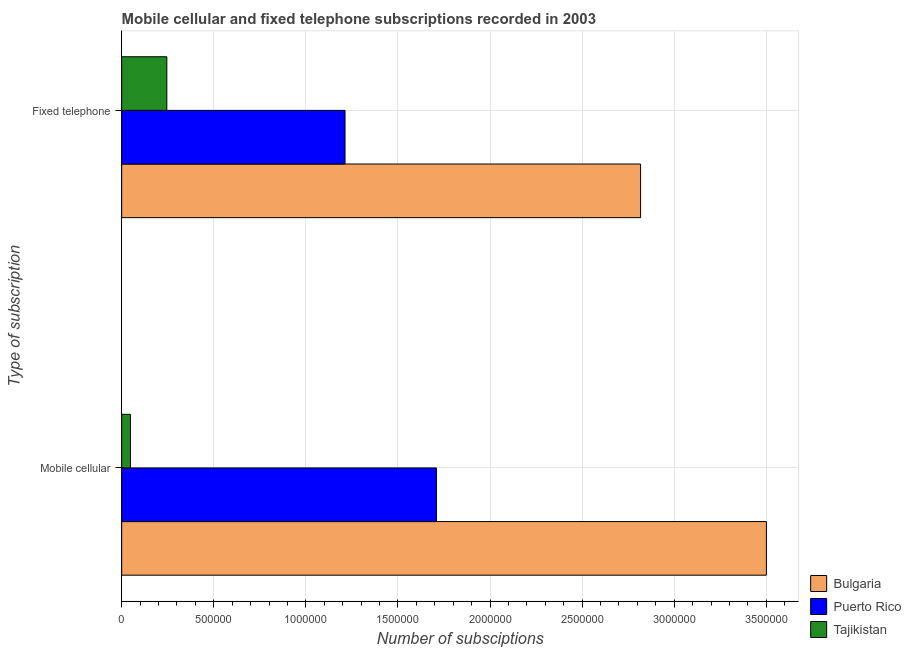How many different coloured bars are there?
Your response must be concise. 3. What is the label of the 2nd group of bars from the top?
Provide a succinct answer. Mobile cellular. What is the number of fixed telephone subscriptions in Bulgaria?
Provide a succinct answer. 2.82e+06. Across all countries, what is the maximum number of mobile cellular subscriptions?
Provide a short and direct response. 3.50e+06. Across all countries, what is the minimum number of fixed telephone subscriptions?
Make the answer very short. 2.45e+05. In which country was the number of fixed telephone subscriptions minimum?
Your answer should be very brief. Tajikistan. What is the total number of fixed telephone subscriptions in the graph?
Offer a terse response. 4.28e+06. What is the difference between the number of fixed telephone subscriptions in Bulgaria and that in Puerto Rico?
Offer a very short reply. 1.60e+06. What is the difference between the number of mobile cellular subscriptions in Bulgaria and the number of fixed telephone subscriptions in Tajikistan?
Ensure brevity in your answer.  3.26e+06. What is the average number of fixed telephone subscriptions per country?
Keep it short and to the point. 1.43e+06. What is the difference between the number of fixed telephone subscriptions and number of mobile cellular subscriptions in Tajikistan?
Provide a succinct answer. 1.98e+05. What is the ratio of the number of fixed telephone subscriptions in Tajikistan to that in Bulgaria?
Make the answer very short. 0.09. Is the number of mobile cellular subscriptions in Puerto Rico less than that in Bulgaria?
Your answer should be compact. Yes. In how many countries, is the number of fixed telephone subscriptions greater than the average number of fixed telephone subscriptions taken over all countries?
Provide a short and direct response. 1. What does the 2nd bar from the top in Fixed telephone represents?
Offer a terse response. Puerto Rico. What is the difference between two consecutive major ticks on the X-axis?
Your answer should be compact. 5.00e+05. Does the graph contain any zero values?
Provide a short and direct response. No. Does the graph contain grids?
Provide a short and direct response. Yes. Where does the legend appear in the graph?
Keep it short and to the point. Bottom right. What is the title of the graph?
Offer a very short reply. Mobile cellular and fixed telephone subscriptions recorded in 2003. What is the label or title of the X-axis?
Offer a very short reply. Number of subsciptions. What is the label or title of the Y-axis?
Offer a very short reply. Type of subscription. What is the Number of subsciptions in Bulgaria in Mobile cellular?
Give a very brief answer. 3.50e+06. What is the Number of subsciptions in Puerto Rico in Mobile cellular?
Give a very brief answer. 1.71e+06. What is the Number of subsciptions in Tajikistan in Mobile cellular?
Offer a very short reply. 4.76e+04. What is the Number of subsciptions in Bulgaria in Fixed telephone?
Provide a succinct answer. 2.82e+06. What is the Number of subsciptions in Puerto Rico in Fixed telephone?
Keep it short and to the point. 1.21e+06. What is the Number of subsciptions of Tajikistan in Fixed telephone?
Offer a very short reply. 2.45e+05. Across all Type of subscription, what is the maximum Number of subsciptions of Bulgaria?
Ensure brevity in your answer.  3.50e+06. Across all Type of subscription, what is the maximum Number of subsciptions of Puerto Rico?
Make the answer very short. 1.71e+06. Across all Type of subscription, what is the maximum Number of subsciptions of Tajikistan?
Provide a succinct answer. 2.45e+05. Across all Type of subscription, what is the minimum Number of subsciptions of Bulgaria?
Offer a very short reply. 2.82e+06. Across all Type of subscription, what is the minimum Number of subsciptions of Puerto Rico?
Provide a short and direct response. 1.21e+06. Across all Type of subscription, what is the minimum Number of subsciptions in Tajikistan?
Provide a short and direct response. 4.76e+04. What is the total Number of subsciptions of Bulgaria in the graph?
Your answer should be compact. 6.32e+06. What is the total Number of subsciptions in Puerto Rico in the graph?
Offer a terse response. 2.92e+06. What is the total Number of subsciptions in Tajikistan in the graph?
Your answer should be very brief. 2.93e+05. What is the difference between the Number of subsciptions in Bulgaria in Mobile cellular and that in Fixed telephone?
Your answer should be very brief. 6.83e+05. What is the difference between the Number of subsciptions in Puerto Rico in Mobile cellular and that in Fixed telephone?
Keep it short and to the point. 4.96e+05. What is the difference between the Number of subsciptions of Tajikistan in Mobile cellular and that in Fixed telephone?
Your answer should be very brief. -1.98e+05. What is the difference between the Number of subsciptions in Bulgaria in Mobile cellular and the Number of subsciptions in Puerto Rico in Fixed telephone?
Make the answer very short. 2.29e+06. What is the difference between the Number of subsciptions of Bulgaria in Mobile cellular and the Number of subsciptions of Tajikistan in Fixed telephone?
Your answer should be very brief. 3.26e+06. What is the difference between the Number of subsciptions in Puerto Rico in Mobile cellular and the Number of subsciptions in Tajikistan in Fixed telephone?
Your response must be concise. 1.46e+06. What is the average Number of subsciptions of Bulgaria per Type of subscription?
Your response must be concise. 3.16e+06. What is the average Number of subsciptions in Puerto Rico per Type of subscription?
Your answer should be compact. 1.46e+06. What is the average Number of subsciptions in Tajikistan per Type of subscription?
Ensure brevity in your answer.  1.46e+05. What is the difference between the Number of subsciptions of Bulgaria and Number of subsciptions of Puerto Rico in Mobile cellular?
Offer a terse response. 1.79e+06. What is the difference between the Number of subsciptions in Bulgaria and Number of subsciptions in Tajikistan in Mobile cellular?
Your answer should be compact. 3.45e+06. What is the difference between the Number of subsciptions of Puerto Rico and Number of subsciptions of Tajikistan in Mobile cellular?
Your answer should be very brief. 1.66e+06. What is the difference between the Number of subsciptions of Bulgaria and Number of subsciptions of Puerto Rico in Fixed telephone?
Make the answer very short. 1.60e+06. What is the difference between the Number of subsciptions of Bulgaria and Number of subsciptions of Tajikistan in Fixed telephone?
Your answer should be compact. 2.57e+06. What is the difference between the Number of subsciptions of Puerto Rico and Number of subsciptions of Tajikistan in Fixed telephone?
Your response must be concise. 9.68e+05. What is the ratio of the Number of subsciptions of Bulgaria in Mobile cellular to that in Fixed telephone?
Provide a short and direct response. 1.24. What is the ratio of the Number of subsciptions in Puerto Rico in Mobile cellular to that in Fixed telephone?
Ensure brevity in your answer.  1.41. What is the ratio of the Number of subsciptions of Tajikistan in Mobile cellular to that in Fixed telephone?
Make the answer very short. 0.19. What is the difference between the highest and the second highest Number of subsciptions of Bulgaria?
Provide a succinct answer. 6.83e+05. What is the difference between the highest and the second highest Number of subsciptions of Puerto Rico?
Your response must be concise. 4.96e+05. What is the difference between the highest and the second highest Number of subsciptions of Tajikistan?
Keep it short and to the point. 1.98e+05. What is the difference between the highest and the lowest Number of subsciptions in Bulgaria?
Give a very brief answer. 6.83e+05. What is the difference between the highest and the lowest Number of subsciptions of Puerto Rico?
Offer a very short reply. 4.96e+05. What is the difference between the highest and the lowest Number of subsciptions of Tajikistan?
Offer a very short reply. 1.98e+05. 